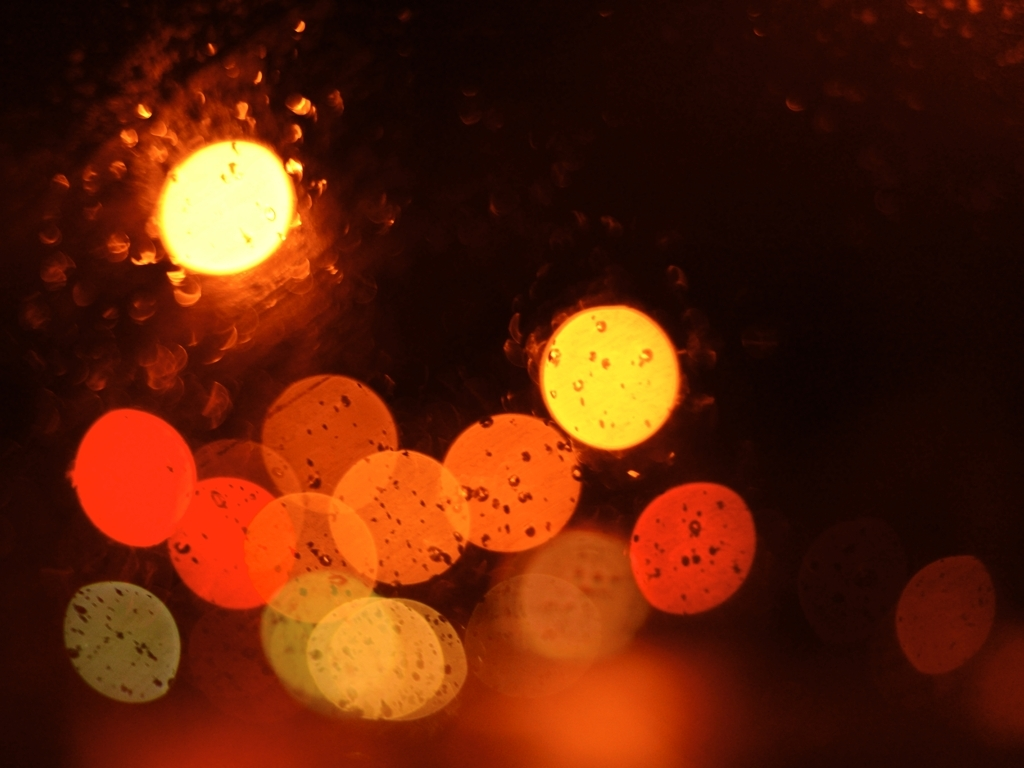Could this image be used for any specific type of graphic design or advertising? Certainly, the abstract quality and the rich, warm color palette of the bokeh effect could lend itself well to backgrounds in graphic design, especially for projects that want to evoke warmth, intimacy, or a sense of relaxation. It might also be used in advertising for products related to autumn, nightlife, or cozy indoor activities. 